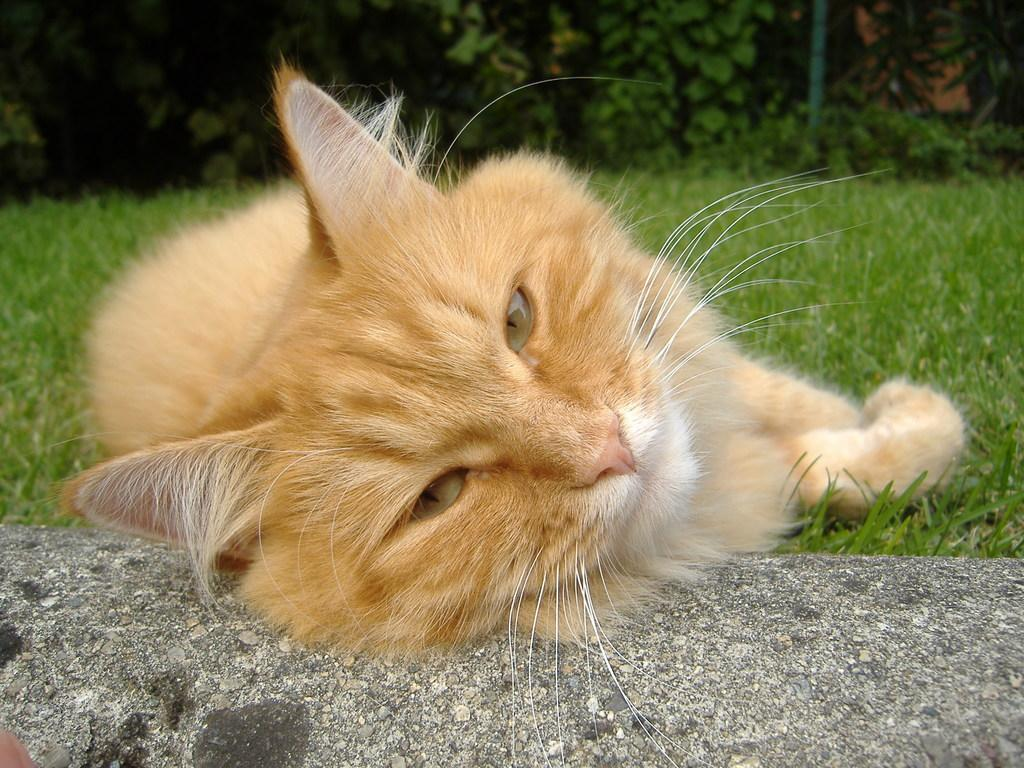What animal can be seen in the image? There is a cat in the image. What is the cat doing in the image? The cat is sleeping on the grass. Where is the cat's head resting? The cat's head is resting on the road. How many chairs can be seen in the image? There are no chairs present in the image. What type of sea creatures can be seen in the image? There are no sea creatures present in the image. 